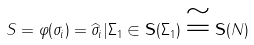<formula> <loc_0><loc_0><loc_500><loc_500>S = \varphi ( \sigma _ { i } ) = \widehat { \sigma } _ { i } | { \Sigma _ { 1 } } \in { \mathbf S } ( \Sigma _ { 1 } ) \cong { \mathbf S } ( N )</formula> 